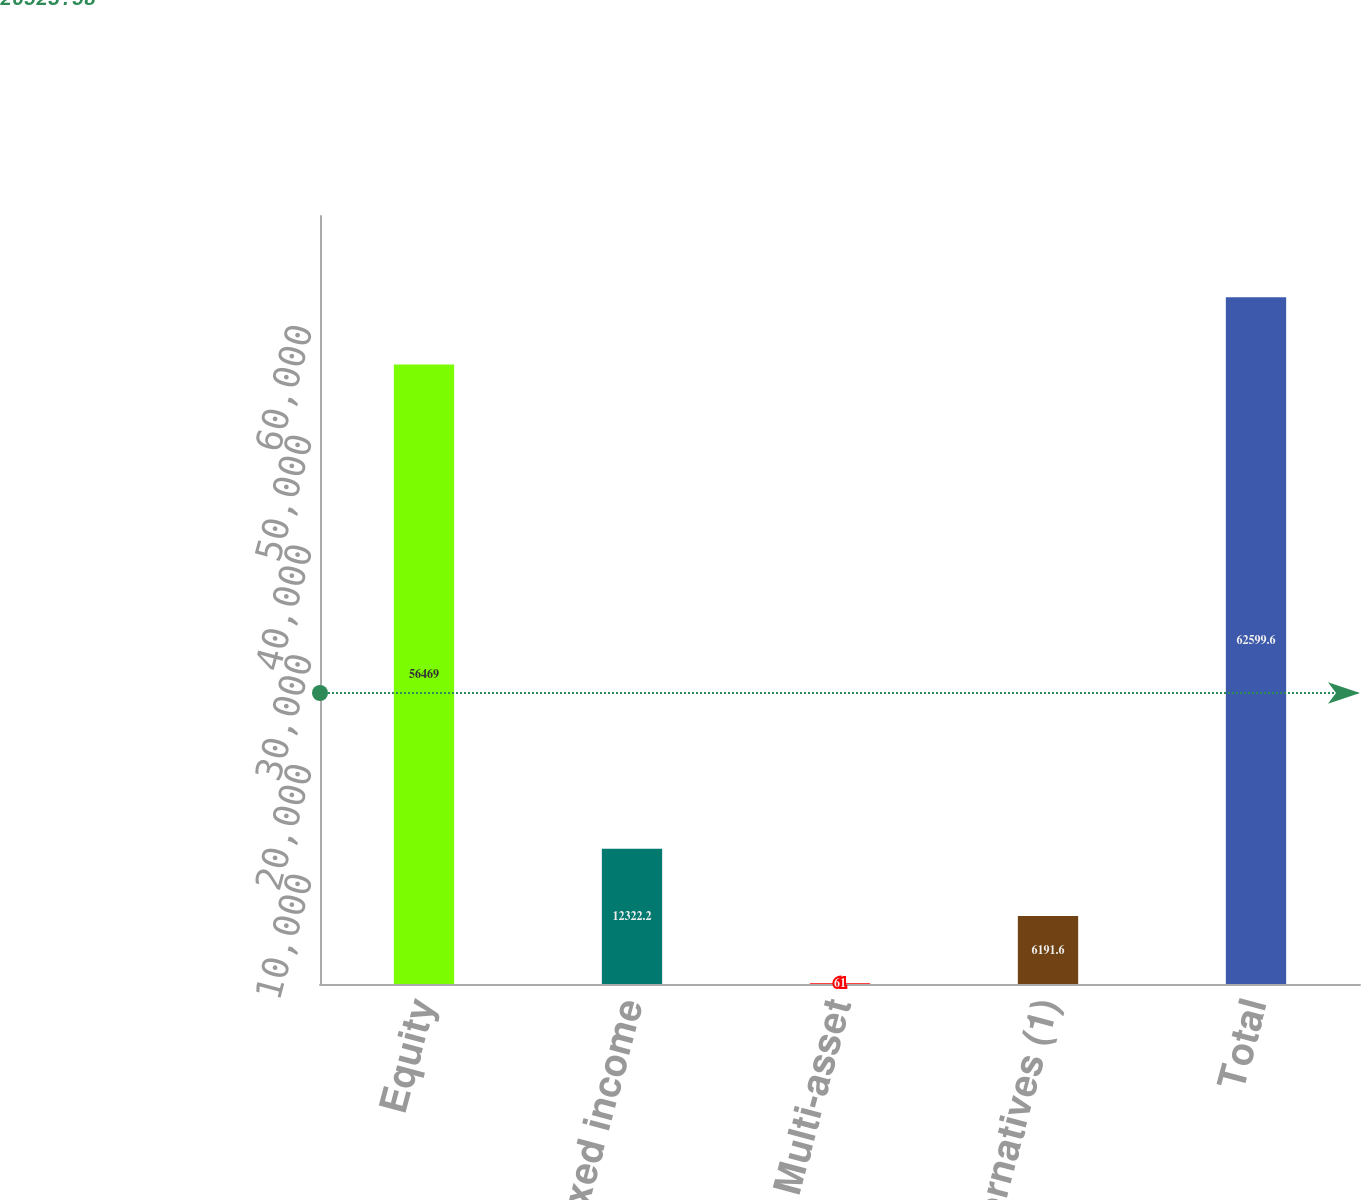Convert chart. <chart><loc_0><loc_0><loc_500><loc_500><bar_chart><fcel>Equity<fcel>Fixed income<fcel>Multi-asset<fcel>Alternatives (1)<fcel>Total<nl><fcel>56469<fcel>12322.2<fcel>61<fcel>6191.6<fcel>62599.6<nl></chart> 